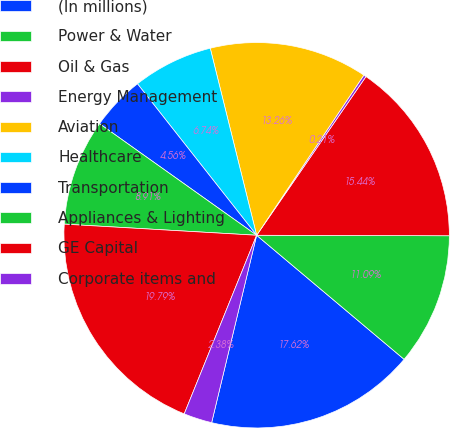Convert chart. <chart><loc_0><loc_0><loc_500><loc_500><pie_chart><fcel>(In millions)<fcel>Power & Water<fcel>Oil & Gas<fcel>Energy Management<fcel>Aviation<fcel>Healthcare<fcel>Transportation<fcel>Appliances & Lighting<fcel>GE Capital<fcel>Corporate items and<nl><fcel>17.62%<fcel>11.09%<fcel>15.44%<fcel>0.21%<fcel>13.26%<fcel>6.74%<fcel>4.56%<fcel>8.91%<fcel>19.79%<fcel>2.38%<nl></chart> 